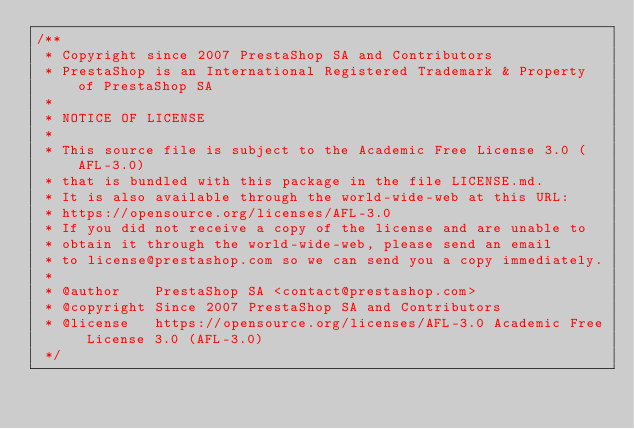<code> <loc_0><loc_0><loc_500><loc_500><_CSS_>/**
 * Copyright since 2007 PrestaShop SA and Contributors
 * PrestaShop is an International Registered Trademark & Property of PrestaShop SA
 *
 * NOTICE OF LICENSE
 *
 * This source file is subject to the Academic Free License 3.0 (AFL-3.0)
 * that is bundled with this package in the file LICENSE.md.
 * It is also available through the world-wide-web at this URL:
 * https://opensource.org/licenses/AFL-3.0
 * If you did not receive a copy of the license and are unable to
 * obtain it through the world-wide-web, please send an email
 * to license@prestashop.com so we can send you a copy immediately.
 *
 * @author    PrestaShop SA <contact@prestashop.com>
 * @copyright Since 2007 PrestaShop SA and Contributors
 * @license   https://opensource.org/licenses/AFL-3.0 Academic Free License 3.0 (AFL-3.0)
 */
</code> 